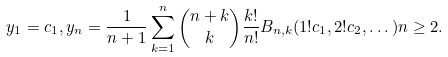<formula> <loc_0><loc_0><loc_500><loc_500>y _ { 1 } = c _ { 1 } , y _ { n } = \frac { 1 } { n + 1 } \sum _ { k = 1 } ^ { n } \binom { n + k } { k } \frac { k ! } { n ! } B _ { n , k } ( 1 ! c _ { 1 } , 2 ! c _ { 2 } , \dots ) n \geq 2 .</formula> 